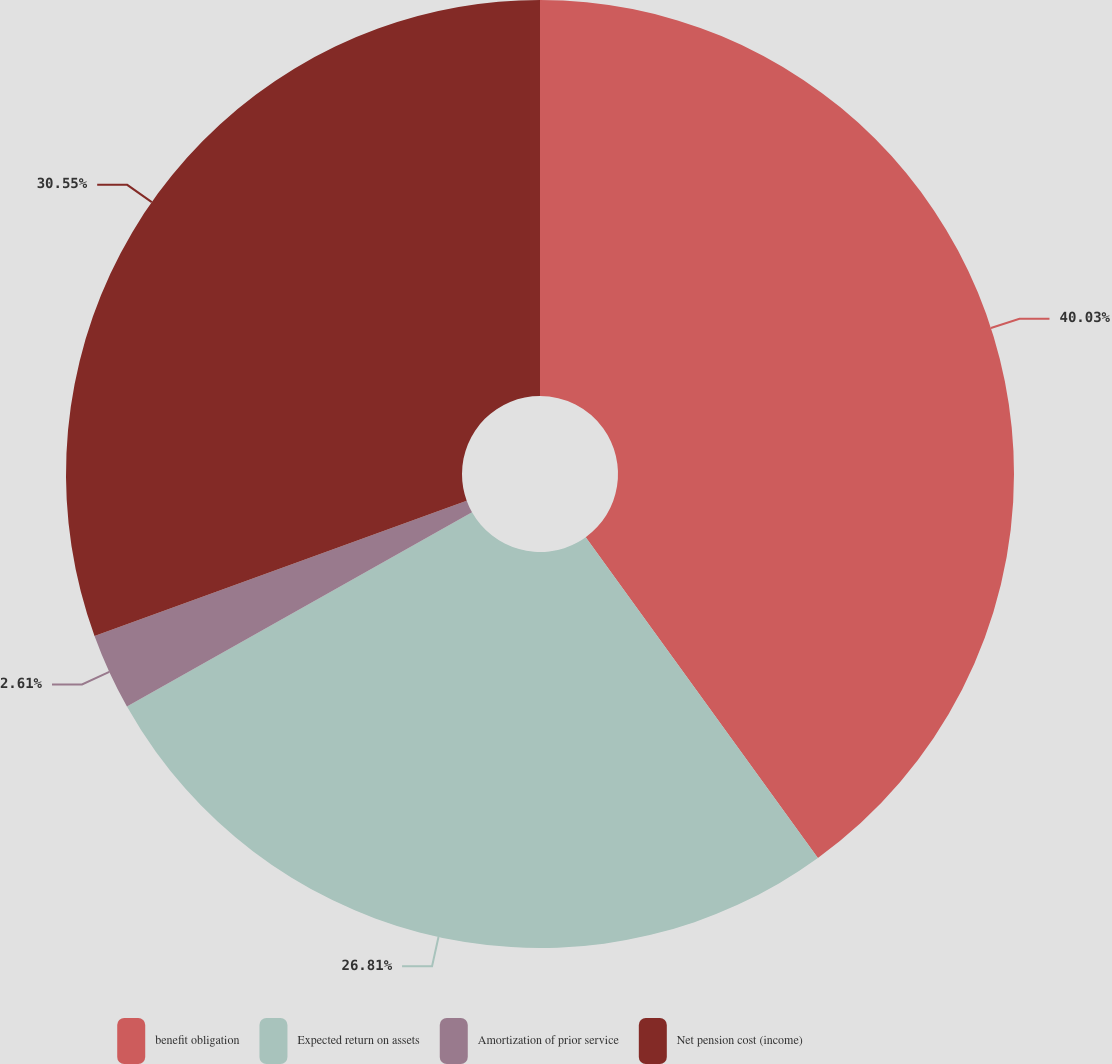Convert chart to OTSL. <chart><loc_0><loc_0><loc_500><loc_500><pie_chart><fcel>benefit obligation<fcel>Expected return on assets<fcel>Amortization of prior service<fcel>Net pension cost (income)<nl><fcel>40.03%<fcel>26.81%<fcel>2.61%<fcel>30.55%<nl></chart> 